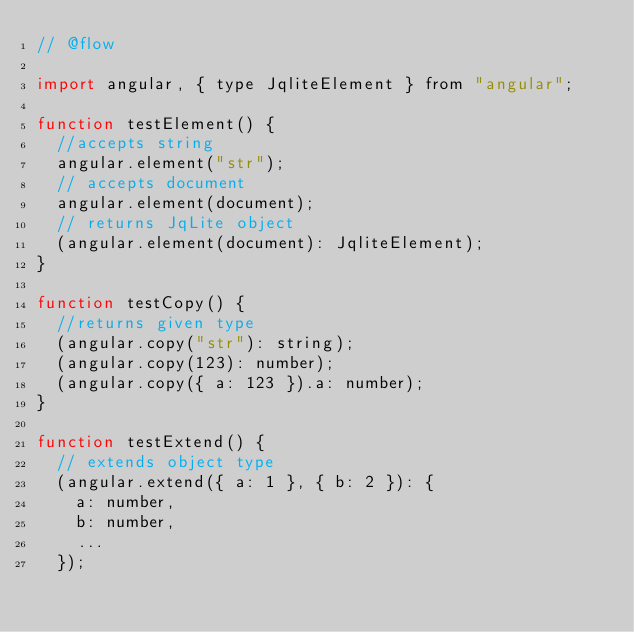<code> <loc_0><loc_0><loc_500><loc_500><_JavaScript_>// @flow

import angular, { type JqliteElement } from "angular";

function testElement() {
  //accepts string
  angular.element("str");
  // accepts document
  angular.element(document);
  // returns JqLite object
  (angular.element(document): JqliteElement);
}

function testCopy() {
  //returns given type
  (angular.copy("str"): string);
  (angular.copy(123): number);
  (angular.copy({ a: 123 }).a: number);
}

function testExtend() {
  // extends object type
  (angular.extend({ a: 1 }, { b: 2 }): {
    a: number,
    b: number,
    ...
  });</code> 